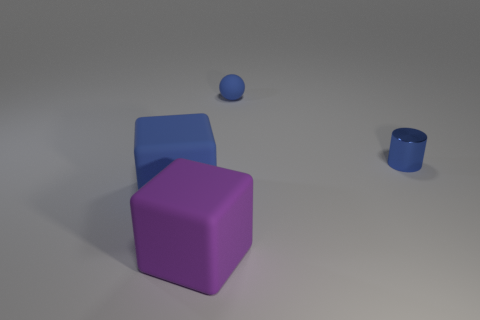There is a large block that is the same color as the small matte thing; what is it made of? Based on the visual qualities and assuming the context of commonly used materials, the large block that shares the same color as the small matte object could likely be made of a plastic or a similarly colored lightweight polymer commonly used in 3D renderings and physical models. 